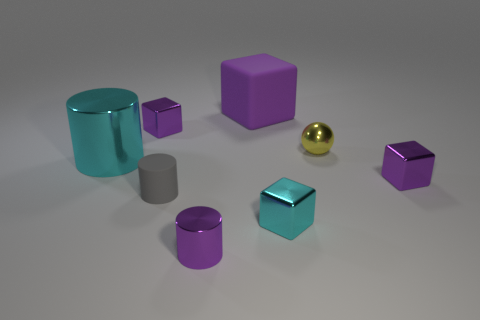Subtract all small purple cylinders. How many cylinders are left? 2 Add 2 big purple cubes. How many objects exist? 10 Subtract all cyan cubes. How many cubes are left? 3 Subtract all balls. How many objects are left? 7 Subtract 2 cylinders. How many cylinders are left? 1 Subtract all gray balls. How many cyan blocks are left? 1 Add 4 cyan things. How many cyan things are left? 6 Add 6 cyan cylinders. How many cyan cylinders exist? 7 Subtract 0 yellow cylinders. How many objects are left? 8 Subtract all blue cylinders. Subtract all red balls. How many cylinders are left? 3 